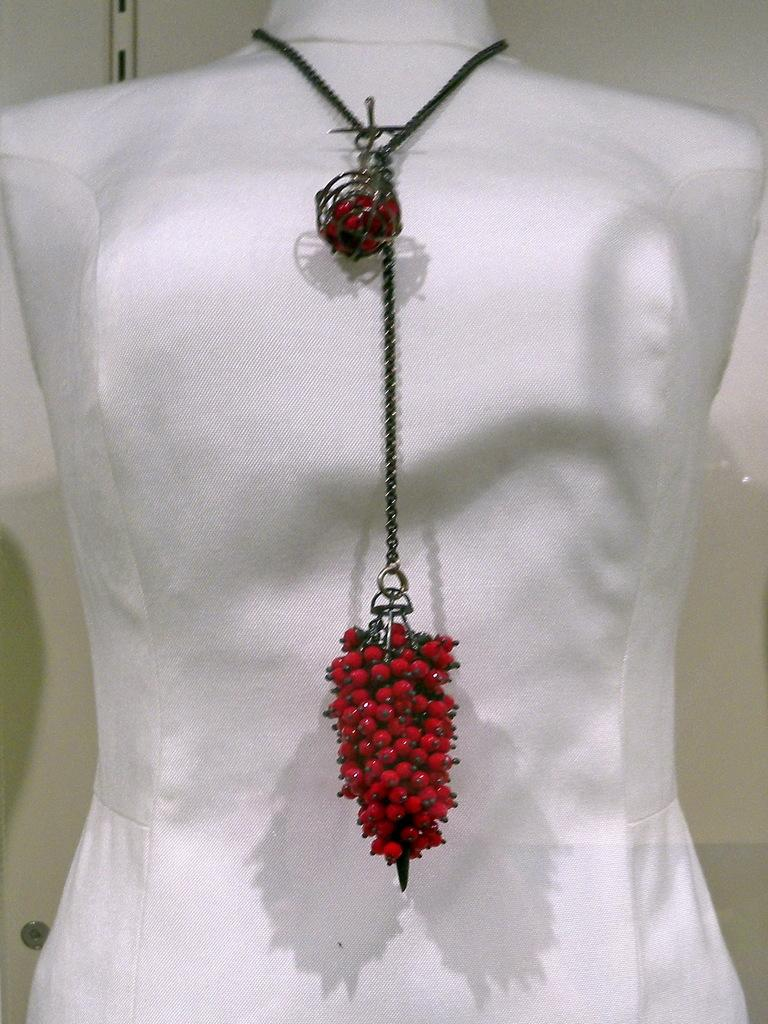What is the main object in the image? The main object in the image is a chain. What color is the bottom part of the chain? The bottom part of the chain is red. What is the chain attached to? The chain is attached to a white object. How many tomatoes are hanging from the chain in the image? There are no tomatoes present in the image; the chain has a red bottom and is attached to a white object. 